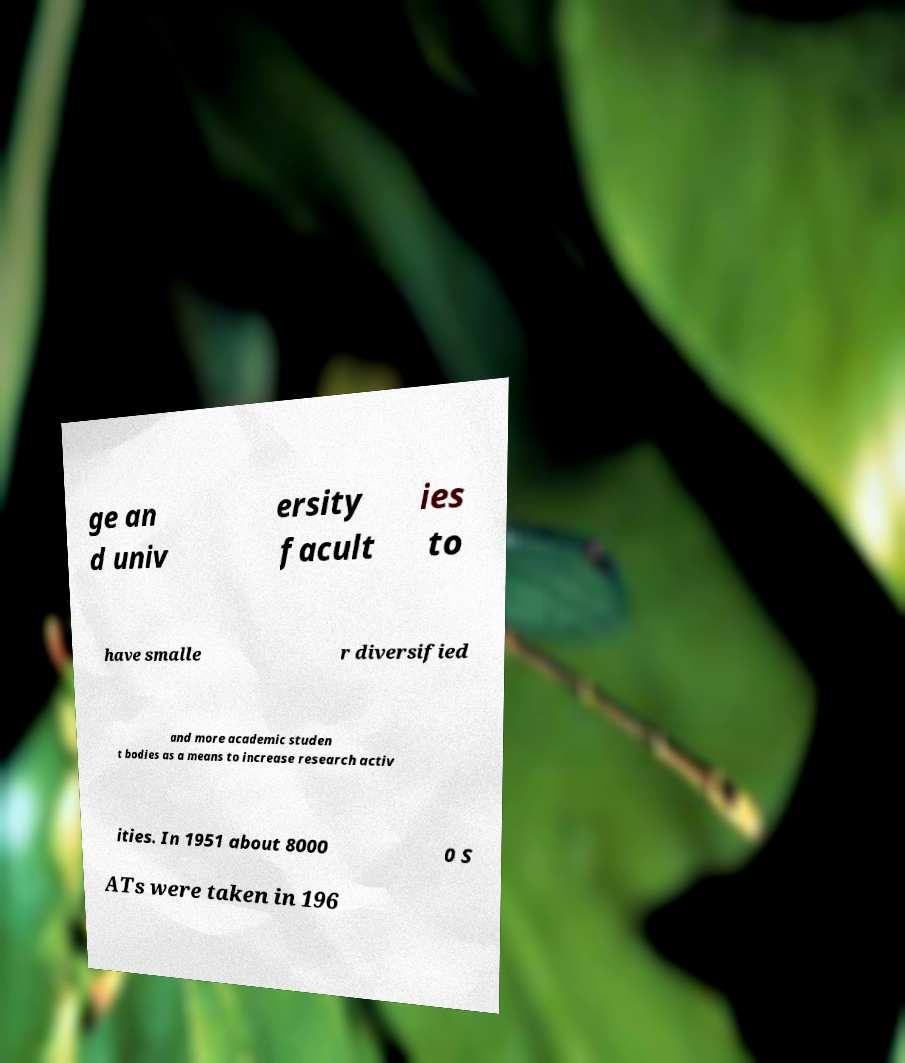Could you extract and type out the text from this image? ge an d univ ersity facult ies to have smalle r diversified and more academic studen t bodies as a means to increase research activ ities. In 1951 about 8000 0 S ATs were taken in 196 